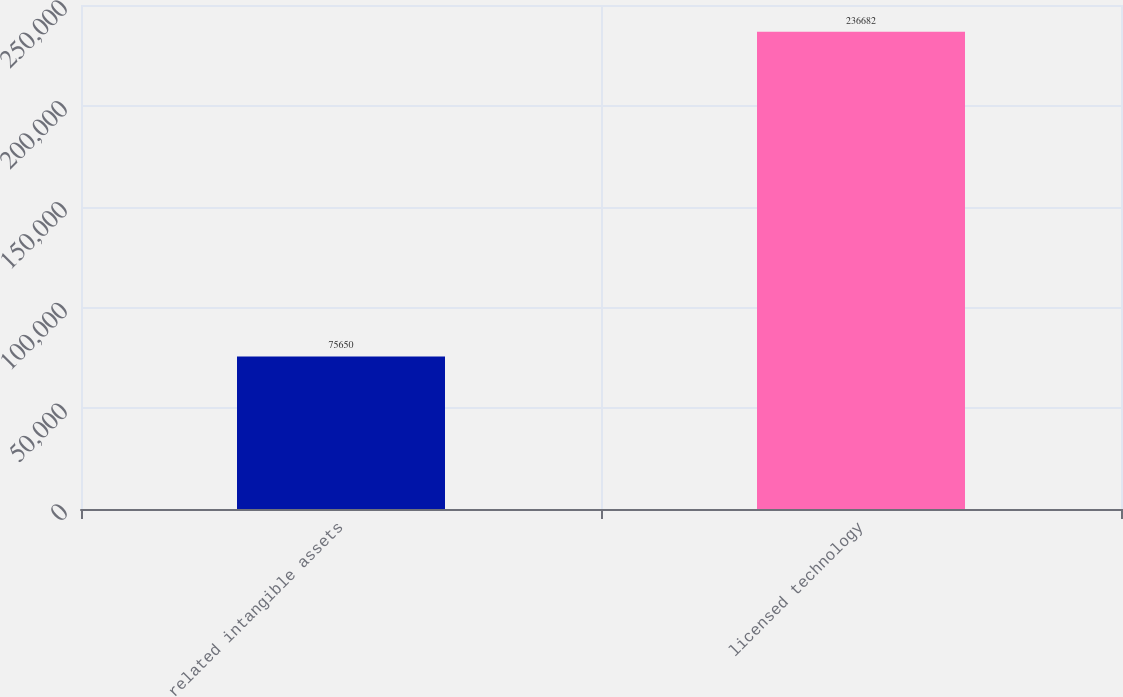Convert chart to OTSL. <chart><loc_0><loc_0><loc_500><loc_500><bar_chart><fcel>related intangible assets<fcel>licensed technology<nl><fcel>75650<fcel>236682<nl></chart> 